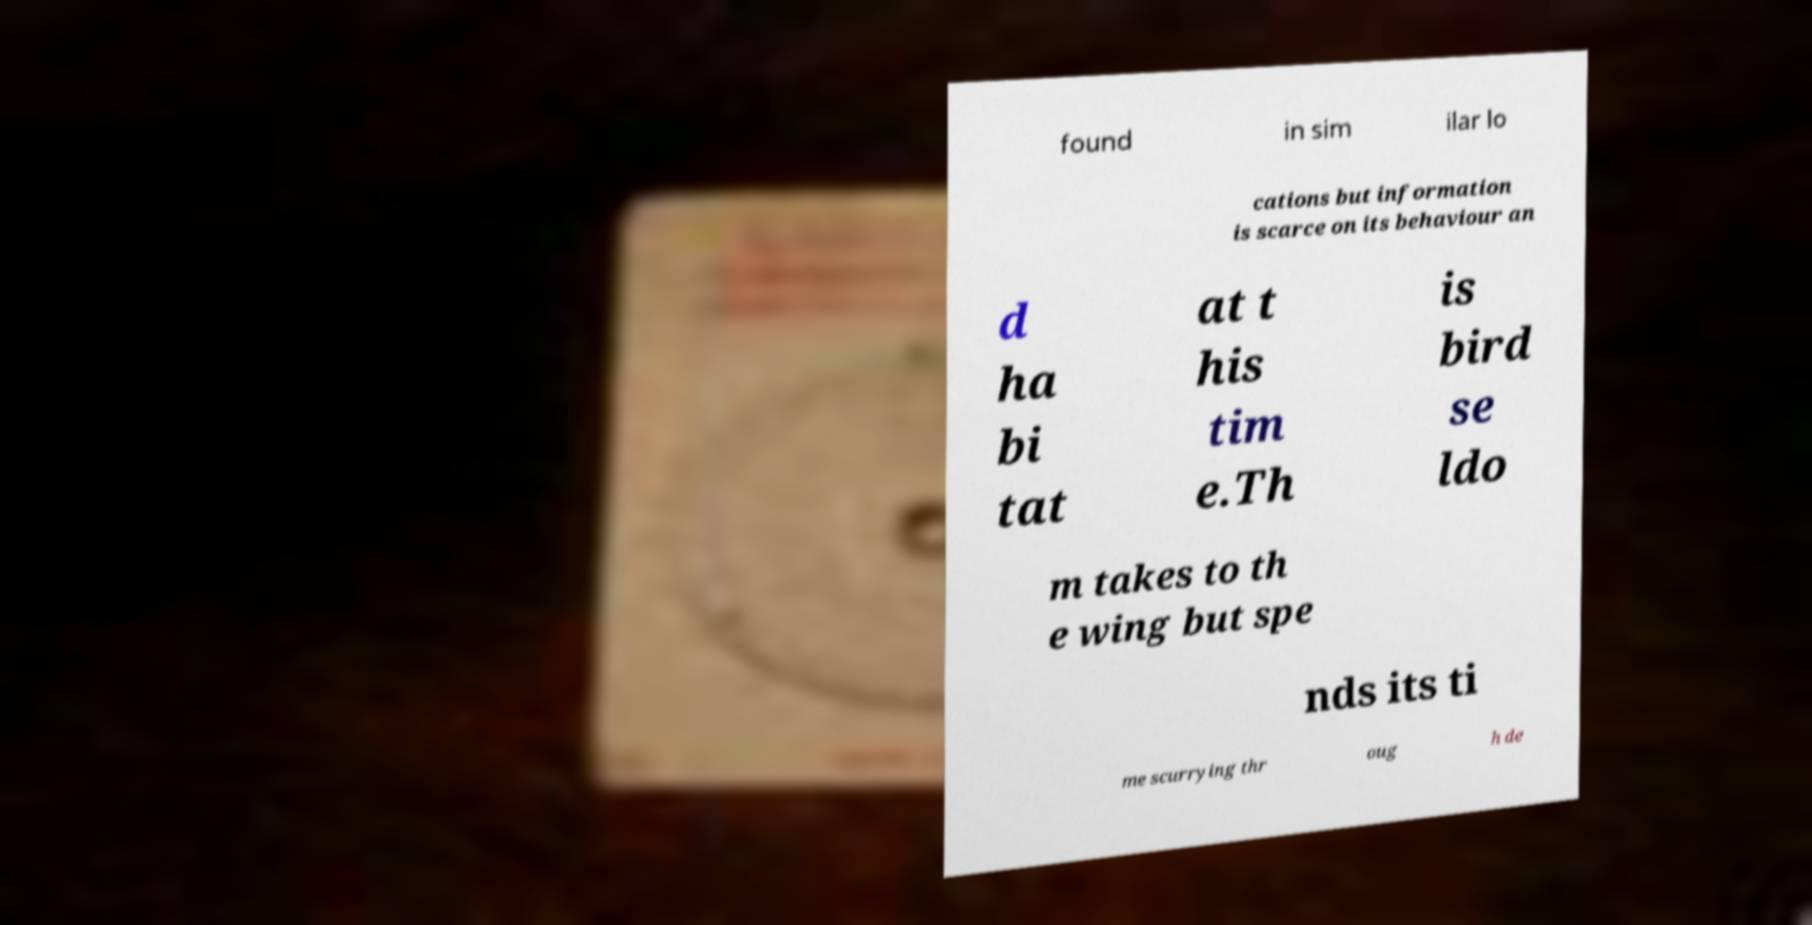What messages or text are displayed in this image? I need them in a readable, typed format. found in sim ilar lo cations but information is scarce on its behaviour an d ha bi tat at t his tim e.Th is bird se ldo m takes to th e wing but spe nds its ti me scurrying thr oug h de 